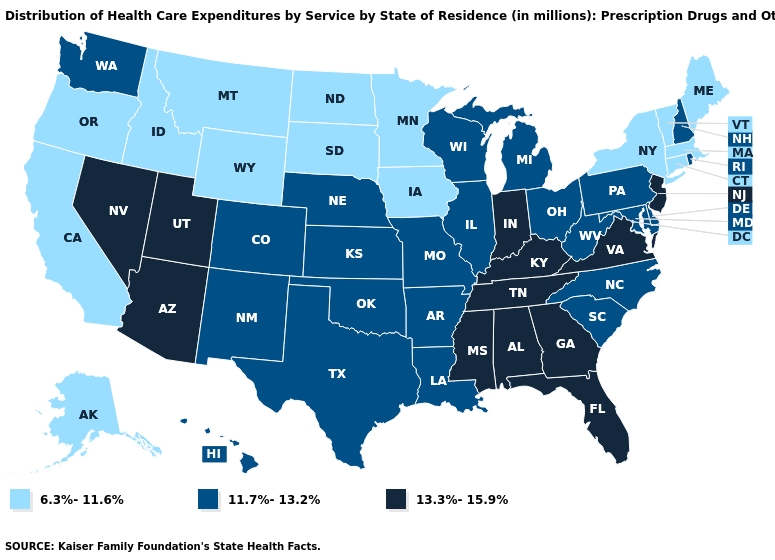Does the map have missing data?
Keep it brief. No. Name the states that have a value in the range 11.7%-13.2%?
Answer briefly. Arkansas, Colorado, Delaware, Hawaii, Illinois, Kansas, Louisiana, Maryland, Michigan, Missouri, Nebraska, New Hampshire, New Mexico, North Carolina, Ohio, Oklahoma, Pennsylvania, Rhode Island, South Carolina, Texas, Washington, West Virginia, Wisconsin. Does Mississippi have the highest value in the USA?
Keep it brief. Yes. Name the states that have a value in the range 6.3%-11.6%?
Short answer required. Alaska, California, Connecticut, Idaho, Iowa, Maine, Massachusetts, Minnesota, Montana, New York, North Dakota, Oregon, South Dakota, Vermont, Wyoming. Name the states that have a value in the range 11.7%-13.2%?
Write a very short answer. Arkansas, Colorado, Delaware, Hawaii, Illinois, Kansas, Louisiana, Maryland, Michigan, Missouri, Nebraska, New Hampshire, New Mexico, North Carolina, Ohio, Oklahoma, Pennsylvania, Rhode Island, South Carolina, Texas, Washington, West Virginia, Wisconsin. What is the highest value in the South ?
Give a very brief answer. 13.3%-15.9%. Does the map have missing data?
Concise answer only. No. Name the states that have a value in the range 6.3%-11.6%?
Concise answer only. Alaska, California, Connecticut, Idaho, Iowa, Maine, Massachusetts, Minnesota, Montana, New York, North Dakota, Oregon, South Dakota, Vermont, Wyoming. Does West Virginia have the lowest value in the South?
Quick response, please. Yes. What is the value of Georgia?
Quick response, please. 13.3%-15.9%. Which states hav the highest value in the West?
Be succinct. Arizona, Nevada, Utah. What is the lowest value in the South?
Give a very brief answer. 11.7%-13.2%. Does the map have missing data?
Concise answer only. No. What is the lowest value in the USA?
Write a very short answer. 6.3%-11.6%. 